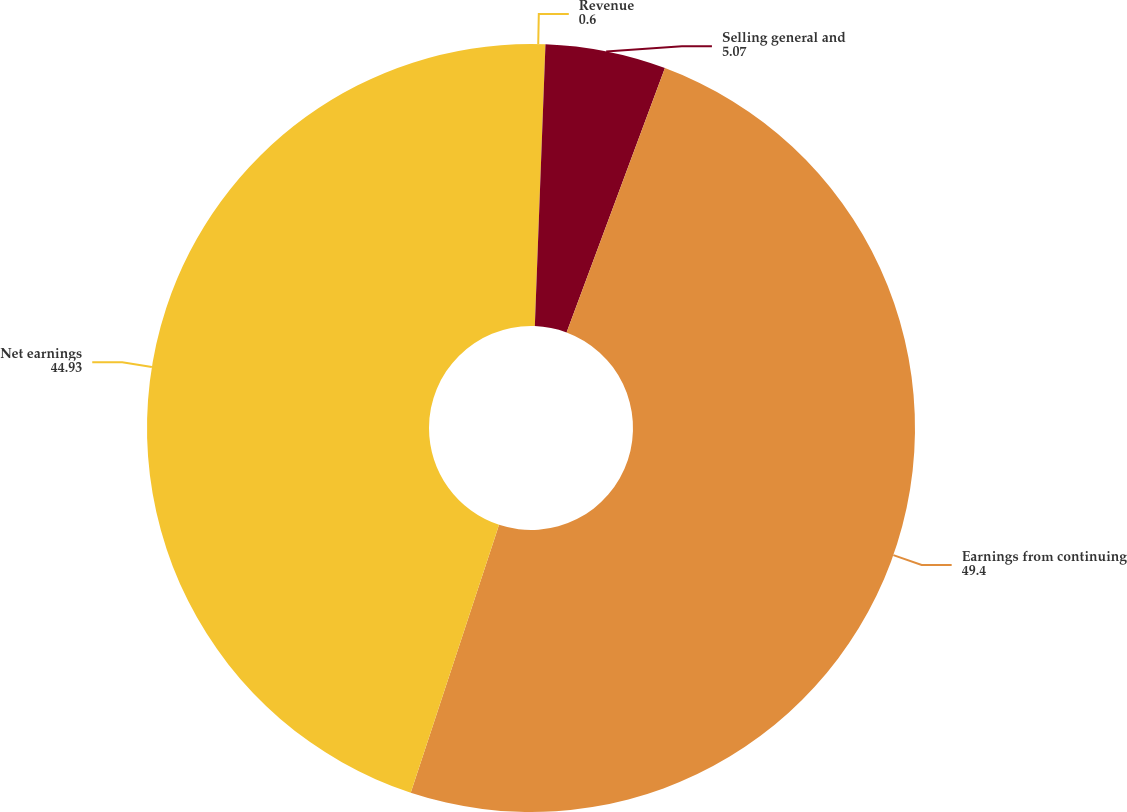Convert chart to OTSL. <chart><loc_0><loc_0><loc_500><loc_500><pie_chart><fcel>Revenue<fcel>Selling general and<fcel>Earnings from continuing<fcel>Net earnings<nl><fcel>0.6%<fcel>5.07%<fcel>49.4%<fcel>44.93%<nl></chart> 